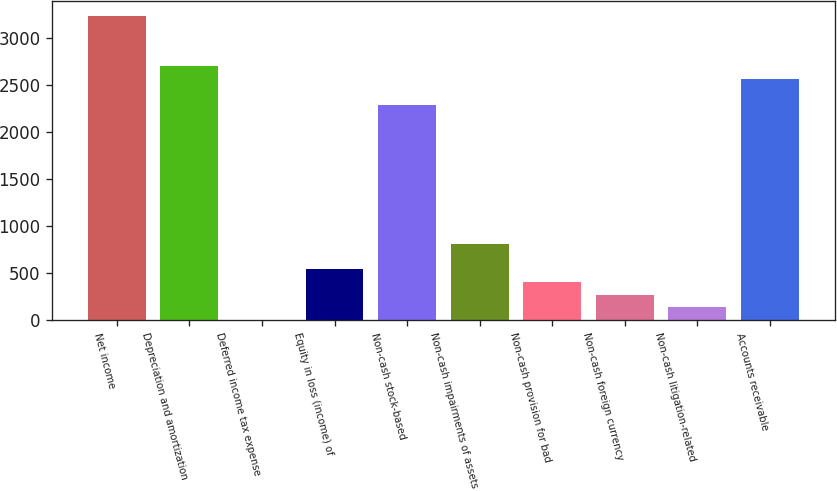Convert chart to OTSL. <chart><loc_0><loc_0><loc_500><loc_500><bar_chart><fcel>Net income<fcel>Depreciation and amortization<fcel>Deferred income tax expense<fcel>Equity in loss (income) of<fcel>Non-cash stock-based<fcel>Non-cash impairments of assets<fcel>Non-cash provision for bad<fcel>Non-cash foreign currency<fcel>Non-cash litigation-related<fcel>Accounts receivable<nl><fcel>3241.88<fcel>2701.6<fcel>0.2<fcel>540.48<fcel>2296.39<fcel>810.62<fcel>405.41<fcel>270.34<fcel>135.27<fcel>2566.53<nl></chart> 